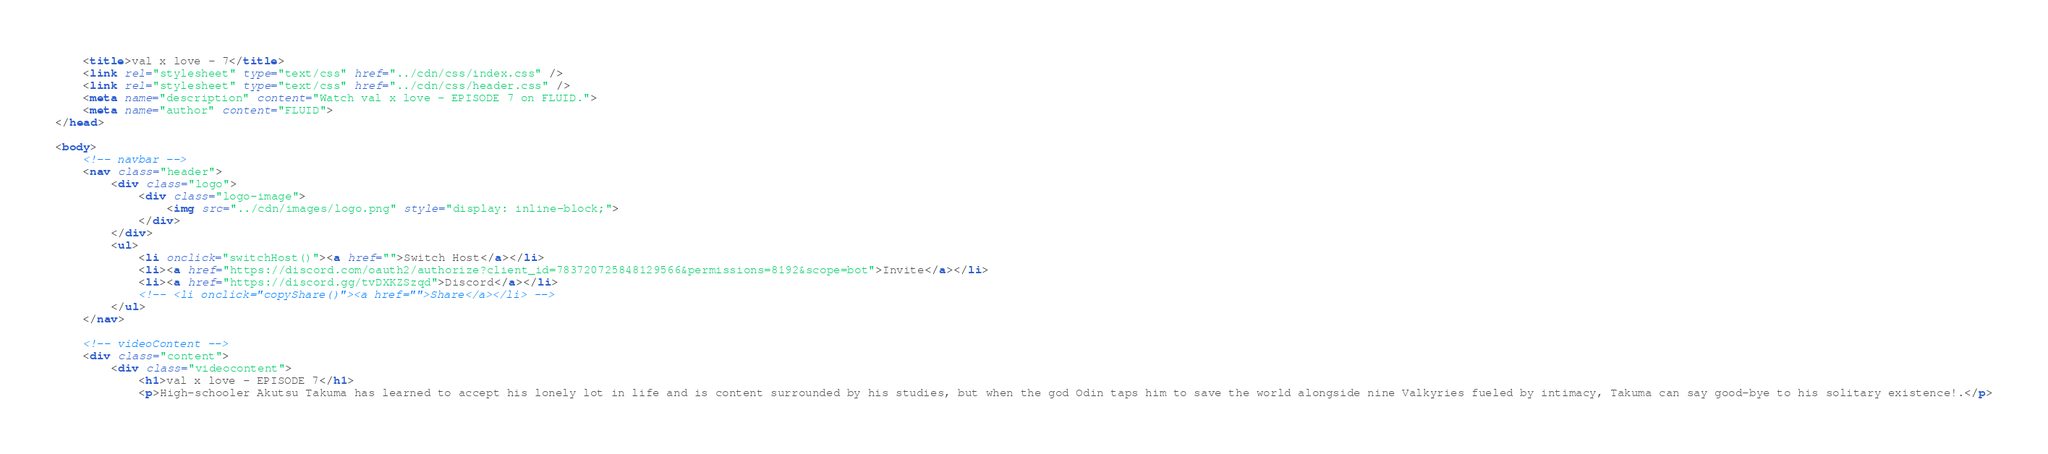<code> <loc_0><loc_0><loc_500><loc_500><_HTML_>    <title>val x love - 7</title>
    <link rel="stylesheet" type="text/css" href="../cdn/css/index.css" />
    <link rel="stylesheet" type="text/css" href="../cdn/css/header.css" />
    <meta name="description" content="Watch val x love - EPISODE 7 on FLUID.">
    <meta name="author" content="FLUID">
</head>

<body>
    <!-- navbar -->
    <nav class="header">
        <div class="logo">
            <div class="logo-image">
                <img src="../cdn/images/logo.png" style="display: inline-block;">
            </div>
        </div>
        <ul>
            <li onclick="switchHost()"><a href="">Switch Host</a></li>
            <li><a href="https://discord.com/oauth2/authorize?client_id=783720725848129566&permissions=8192&scope=bot">Invite</a></li>
            <li><a href="https://discord.gg/tvDXKZSzqd">Discord</a></li>
            <!-- <li onclick="copyShare()"><a href="">Share</a></li> -->
        </ul>
    </nav>

    <!-- videoContent -->
    <div class="content">
        <div class="videocontent">
            <h1>val x love - EPISODE 7</h1>
            <p>High-schooler Akutsu Takuma has learned to accept his lonely lot in life and is content surrounded by his studies, but when the god Odin taps him to save the world alongside nine Valkyries fueled by intimacy, Takuma can say good-bye to his solitary existence!.</p></code> 